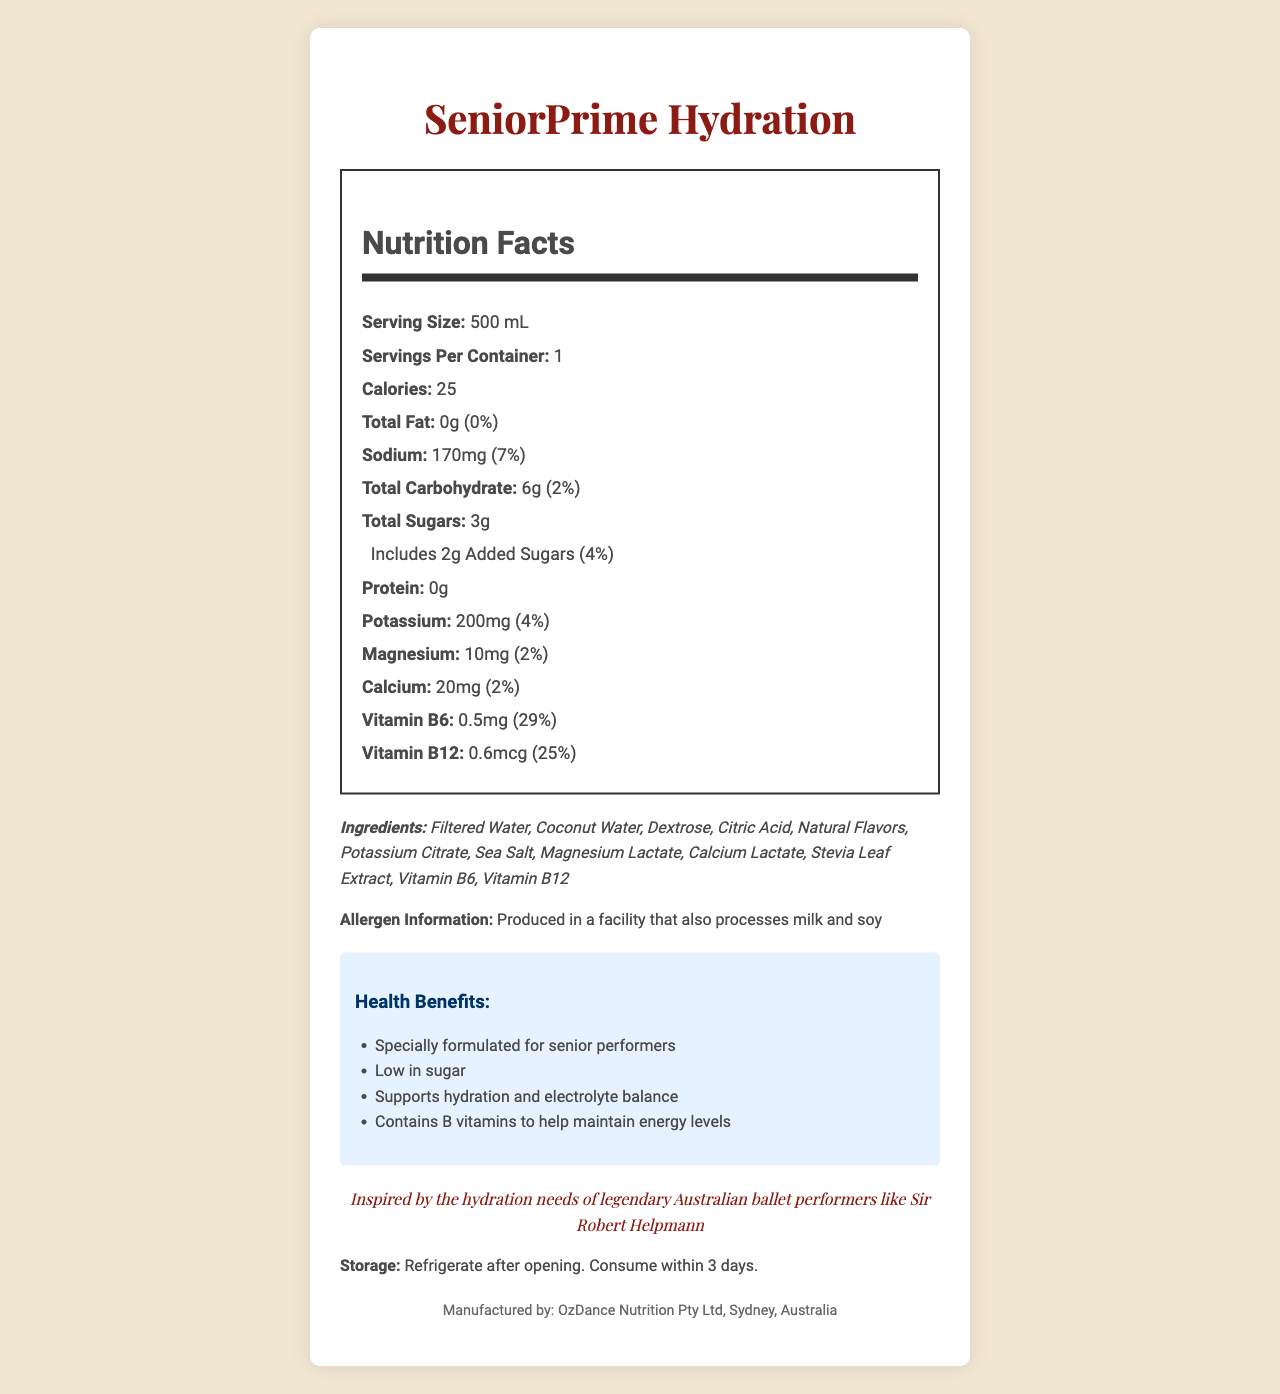what is the serving size for SeniorPrime Hydration? The serving size is explicitly listed as "500 mL" in the Nutrition Facts.
Answer: 500 mL How many calories are there per serving in SeniorPrime Hydration? The document states that there are 25 calories per serving.
Answer: 25 What percent of daily sodium intake does one serving provide? The document mentions that one serving contains 170mg of sodium, which is 7% of the daily value.
Answer: 7% List three main electrolytes found in SeniorPrime Hydration. The key electrolytes listed in the document are Sodium (170mg), Potassium (200mg), and Magnesium (10mg).
Answer: Sodium, Potassium, Magnesium What is the total carbohydrate content per serving in SeniorPrime Hydration? The document states that the total carbohydrate content is 6g per serving.
Answer: 6g Which of the following ingredients is not listed in SeniorPrime Hydration? A. Dextrose B. Ascorbic Acid C. Stevia Leaf Extract D. Natural Flavors Ascorbic Acid is not listed in the ingredients, unlike the other options which are mentioned.
Answer: B What is the percentage of the Vitamin B6 daily value provided by one serving? A. 29% B. 25% C. 20% D. 15% The document states that Vitamin B6 has a daily value of 29% per serving.
Answer: A Is SeniorPrime Hydration low in sugar? The health claims section states that the product is low in sugar.
Answer: Yes Summarize the main benefits of SeniorPrime Hydration. The main benefits mentioned include being low in sugar, supporting hydration and electrolyte balance, and providing B vitamins for energy.
Answer: Low in sugar, supports hydration, contains essential electrolytes, and helps maintain energy levels through B vitamins What is the allergen information for SeniorPrime Hydration? The allergen information indicates that it is produced in a facility that processes milk and soy.
Answer: Produced in a facility that also processes milk and soy Describe the recommended storage instructions for SeniorPrime Hydration. The document specifies to refrigerate after opening and consume within 3 days.
Answer: Refrigerate after opening. Consume within 3 days. What is the source of sweetness in SeniorPrime Hydration? Stevia Leaf Extract is listed as one of the ingredients, providing natural sweetness.
Answer: Stevia Leaf Extract Does SeniorPrime Hydration contain any protein? The document shows that the protein content is 0g per serving.
Answer: No Who is the manufacturer of SeniorPrime Hydration? The footnote in the document states that OzDance Nutrition Pty Ltd in Sydney, Australia is the manufacturer.
Answer: OzDance Nutrition Pty Ltd, Sydney, Australia Can you determine the expiry date of SeniorPrime Hydration from the document? The document does not provide any information on the expiry date of the product.
Answer: Not enough information 